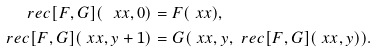Convert formula to latex. <formula><loc_0><loc_0><loc_500><loc_500>\ r e c [ F , G ] ( \ x x , 0 ) & = F ( \ x x ) , \\ \ r e c [ F , G ] ( \ x x , y + 1 ) & = G ( \ x x , y , \ r e c [ F , G ] ( \ x x , y ) ) .</formula> 